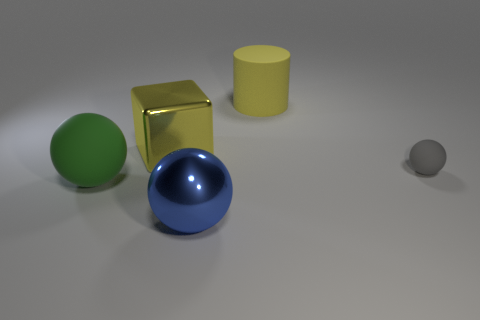Can you describe the lighting conditions in the scene? The lighting in the image is soft and seems to be coming from the top, as indicated by the gentle shadows under the objects. There's a mild shine on the blue sphere and yellow cylinder, suggesting a light source above and slightly to the left. 